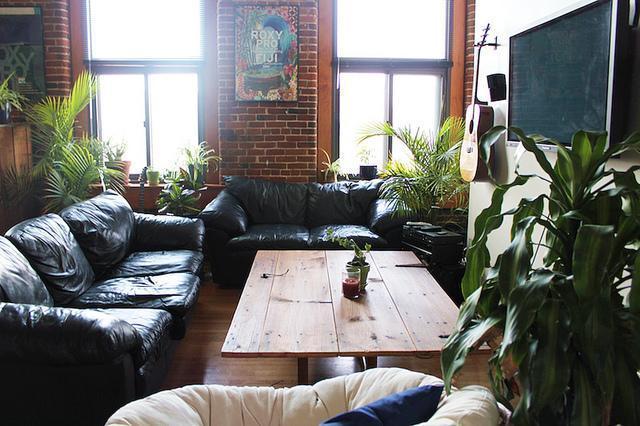How many potted plants are visible?
Give a very brief answer. 3. How many couches are there?
Give a very brief answer. 2. 